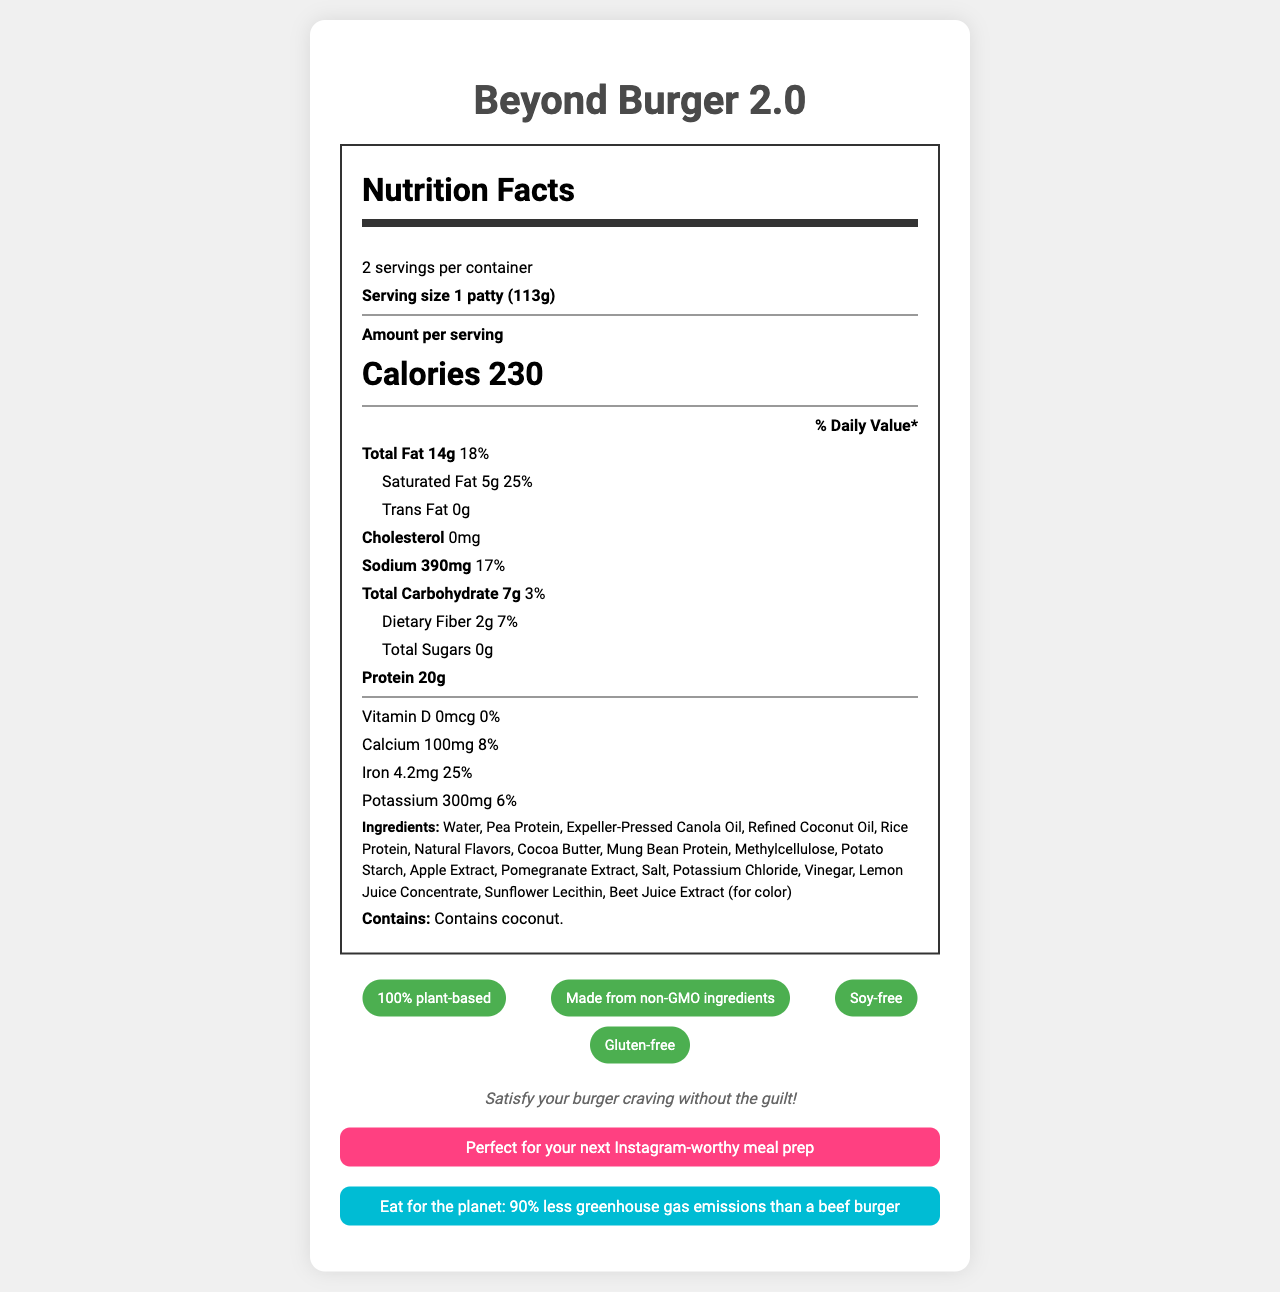what is the serving size? The document states that the serving size is 1 patty (113g).
Answer: 1 patty (113g) how many calories are in one serving? According to the document, each serving contains 230 calories.
Answer: 230 how much protein is in one patty? The label shows that one serving has 20g of protein.
Answer: 20g is the product gluten-free? The document claims that the product is gluten-free.
Answer: Yes what is the primary source of protein in the ingredients? In the list of ingredients, pea protein is listed as the primary source of protein.
Answer: Pea Protein which of the following nutrients has the highest % Daily Value per serving? A. Sodium B. Iron C. Saturated Fat Saturated fat has a 25% Daily Value, which is the highest among the listed nutrients.
Answer: C how many servings are in the container? The document indicates that there are 2 servings per container.
Answer: 2 is there any cholesterol in the Beyond Burger 2.0? The document shows that there is 0mg of cholesterol in the product.
Answer: No what is the amount of dietary fiber per serving? The label states that there is 2g of dietary fiber per serving.
Answer: 2g what percent of your daily sodium intake will one serving of Beyond Burger 2.0 provide? The document shows that one serving provides 17% of the daily value for sodium.
Answer: 17% what ingredients give the burger its color? A. Beet Juice Extract B. Cocoa Butter C. Pomegranate Extract D. Apple Extract The document specifies that beet juice extract is used for color.
Answer: A does the product contain any allergens? It contains coconut, as indicated in the allergen information section of the document.
Answer: Yes summarize the entire document The explanation includes all major points of the document concerning nutritional content, claims, ingredients, and promotional messages.
Answer: The Beyond Burger 2.0 Nutrition Facts Label provides information on the serving size (1 patty, 113g), servings per container (2), and the nutritional content per serving including calories (230), total fat (14g, 18% DV), saturated fat (5g, 25% DV), trans fat (0g), cholesterol (0mg), sodium (390mg, 17% DV), total carbohydrate (7g, 3% DV), dietary fiber (2g, 7% DV), total sugars (0g), and protein (20g). It lists the amounts of essential nutrients such as vitamin D (0mcg, 0% DV), calcium (100mg, 8% DV), iron (4.2mg, 25% DV), and potassium (300mg, 6% DV). The document also includes a list of ingredients, allergen information, and various claims such as being 100% plant-based, non-GMO, soy-free, and gluten-free. Furthermore, it includes promotional messages about satisfying burger cravings without guilt, making Instagram-worthy meals, and having a positive environmental impact. how many calories are in the entire container? Since there are 2 servings per container and each serving contains 230 calories, the total calories for the entire container is 230 calories x 2 = 460 calories.
Answer: 460 what is the main idea of the sustainability message? The sustainability message aims to highlight the environmental benefits of the Beyond Burger 2.0 as it produces 90% less greenhouse gas emissions than a typical beef burger.
Answer: Eat for the planet: 90% less greenhouse gas emissions than a beef burger what type of oil is used in the product? The ingredients list includes expeller-pressed canola oil.
Answer: Expeller-Pressed Canola Oil what vitamins are present in the product? The document states that vitamin D is 0mcg with 0% daily value, indicating that no vitamins are present.
Answer: None which TV show airs the commercial for this burger? The product is advertised during commercial breaks of 'Euphoria', according to the document.
Answer: 'Euphoria' what is the source of the ingredient "Natural Flavors"? The document does not provide information on the source of the ingredient "Natural Flavors".
Answer: I don't know what is the daily value percentage of total carbohydrates per serving? A. 1% B. 3% C. 7% D. 14% The document shows a 3% daily value for total carbohydrates per serving.
Answer: B 